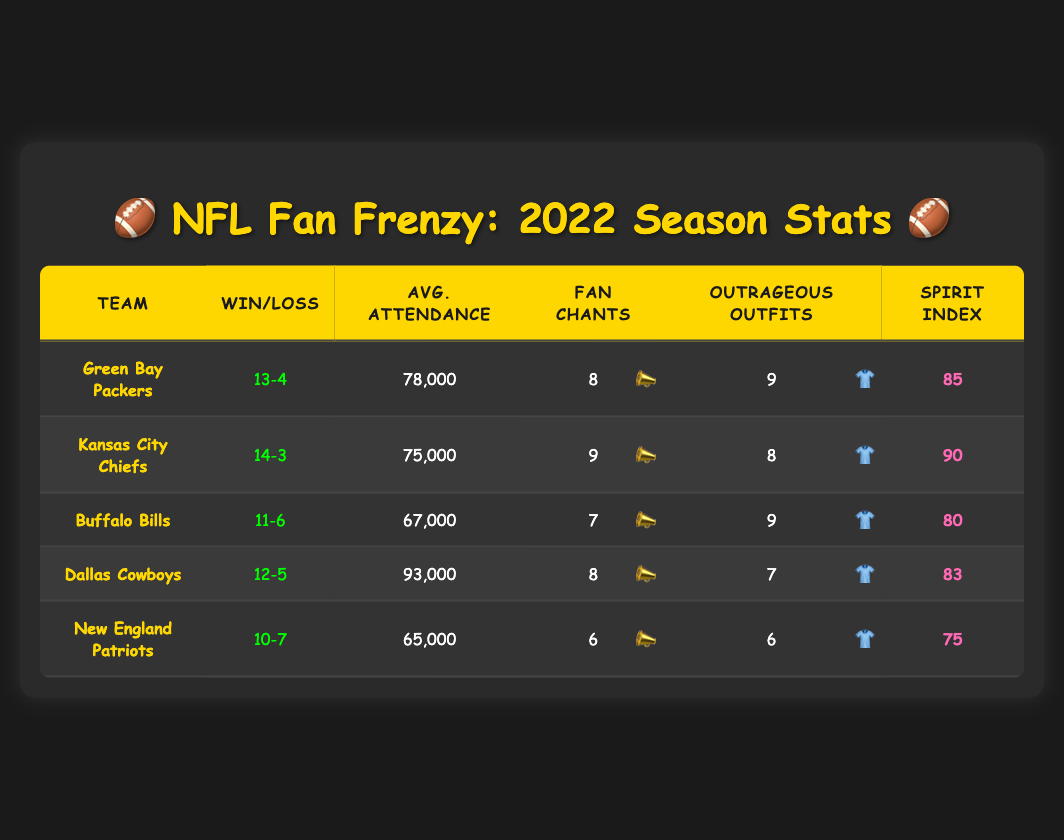What is the win-loss record of the Buffalo Bills? The Buffalo Bills' data shows a win-loss record listed as "11-6." This is directly pulled from the table under the respective team’s row.
Answer: 11-6 Which team had the highest average attendance in 2022? The average attendance figures are listed for each team. By comparing them, the Dallas Cowboys have the highest attendance at 93,000, as seen in their row of the table.
Answer: 93,000 What is the sum of the fan chants scores for the Green Bay Packers and the Kansas City Chiefs? The fan chants scores for the specified teams are 8 for the Packers and 9 for the Chiefs. Adding these together gives 8 + 9 = 17.
Answer: 17 Did the New England Patriots have a higher spirit index than the Buffalo Bills? The spirit index for the New England Patriots is 75, while the Buffalo Bills have a spirit index of 80. Since 75 is less than 80, the statement is false.
Answer: No What is the average spirit index of all teams listed? To find the average spirit index, sum the spirit indices: 85 (Packers) + 90 (Chiefs) + 80 (Bills) + 83 (Cowboys) + 75 (Patriots) = 413. There are 5 teams, so the average is 413 / 5 = 82.6.
Answer: 82.6 Which team has both an outrageous outfits score and a fan chants score that are both greater than or equal to 8? Looking at both scores, the Kansas City Chiefs have an 8 for outrageous outfits and a 9 for fan chants, satisfying the condition. The Green Bay Packers also satisfy this with scores of 9 and 8 respectively.
Answer: Kansas City Chiefs, Green Bay Packers How many teams had a win-loss record of 12 games or more? The teams with win-loss records of 12 or more games are the Packers (13-4), Chiefs (14-3), and Cowboys (12-5), giving a total of 3 teams.
Answer: 3 What was the spirit index of the team with the lowest average attendance? The team with the lowest average attendance is the New England Patriots, with an attendance of 65,000. Their spirit index is 75, as shown in their row.
Answer: 75 Which team scored lower than 8 in fan chants but higher than 7 in outrageous outfits? The Buffalo Bills scored 7 in fan chants and 9 in outrageous outfits, which fits the criteria of having a fan chant score lower than 8 but an outrageous outfits score higher than 7.
Answer: Buffalo Bills 